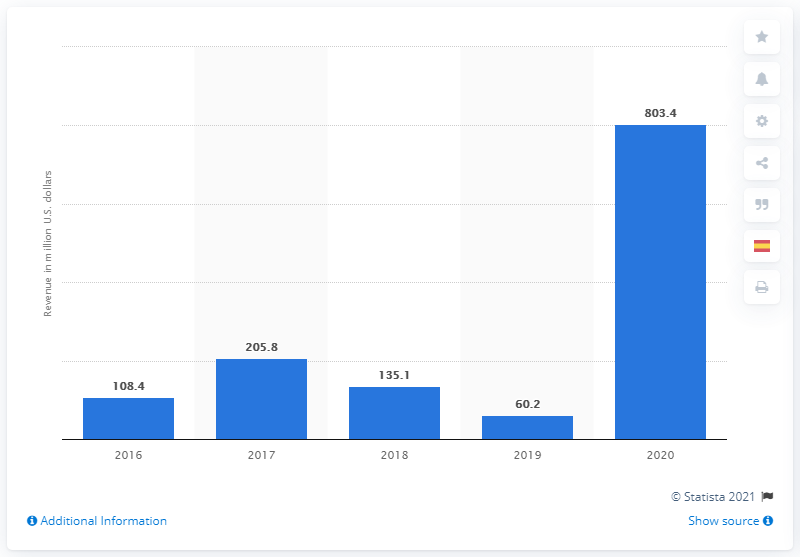Outline some significant characteristics in this image. In 2020, Moderna's total revenue was 803.4 million. 